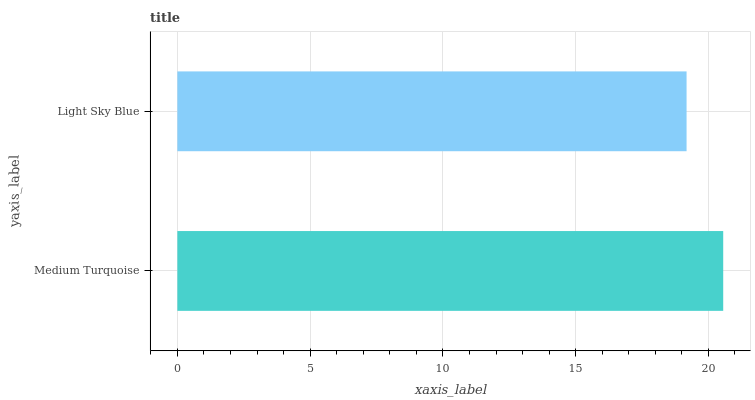Is Light Sky Blue the minimum?
Answer yes or no. Yes. Is Medium Turquoise the maximum?
Answer yes or no. Yes. Is Light Sky Blue the maximum?
Answer yes or no. No. Is Medium Turquoise greater than Light Sky Blue?
Answer yes or no. Yes. Is Light Sky Blue less than Medium Turquoise?
Answer yes or no. Yes. Is Light Sky Blue greater than Medium Turquoise?
Answer yes or no. No. Is Medium Turquoise less than Light Sky Blue?
Answer yes or no. No. Is Medium Turquoise the high median?
Answer yes or no. Yes. Is Light Sky Blue the low median?
Answer yes or no. Yes. Is Light Sky Blue the high median?
Answer yes or no. No. Is Medium Turquoise the low median?
Answer yes or no. No. 